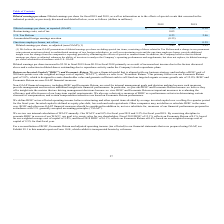From Plexus's financial document, Which years does the table provide information for diluted earnings per share? The document shows two values: 2019 and 2018. From the document: "2019 2018 2019 2018..." Also, What was the diluted earnings per share in 2019? According to the financial document, 3.50. The relevant text states: "Diluted earnings per share, as reported (GAAP) $ 3.50 $ 0.38..." Also, What was the amount of U.S. Tax Reform in 2019? According to the financial document, 0.23 (in millions). The relevant text states: "U.S. Tax Reform 0.23 2.46..." Additionally, Which years did Diluted earnings per share, as adjusted (non-GAAP) exceed $3 million? The document shows two values: 2019 and 2018. From the document: "2019 2018 2019 2018..." Also, can you calculate: What was the change in the amount of U.S Tax Reform between 2018 and 2019? Based on the calculation: 0.23-2.46, the result is -2.23 (in millions). This is based on the information: "U.S. Tax Reform 0.23 2.46 U.S. Tax Reform 0.23 2.46..." The key data points involved are: 0.23, 2.46. Also, can you calculate: What was the percentage change in diluted earnings per share between 2018 and 2019? To answer this question, I need to perform calculations using the financial data. The calculation is: (3.50-0.38)/0.38, which equals 821.05 (percentage). This is based on the information: "d earnings per share, as reported (GAAP) $ 3.50 $ 0.38 Diluted earnings per share, as reported (GAAP) $ 3.50 $ 0.38..." The key data points involved are: 0.38, 3.50. 